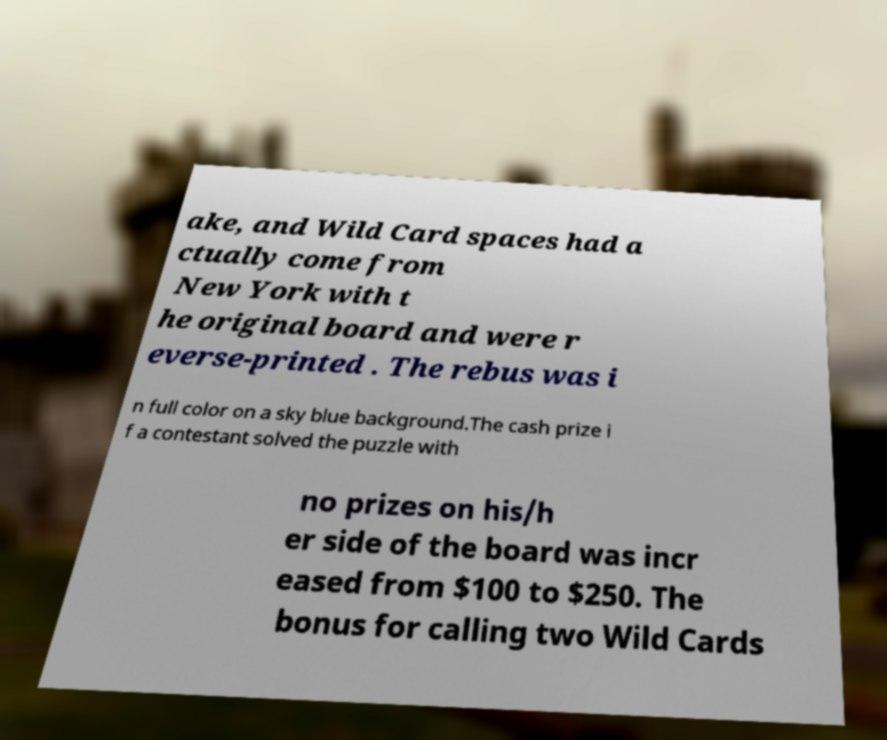Can you read and provide the text displayed in the image?This photo seems to have some interesting text. Can you extract and type it out for me? ake, and Wild Card spaces had a ctually come from New York with t he original board and were r everse-printed . The rebus was i n full color on a sky blue background.The cash prize i f a contestant solved the puzzle with no prizes on his/h er side of the board was incr eased from $100 to $250. The bonus for calling two Wild Cards 